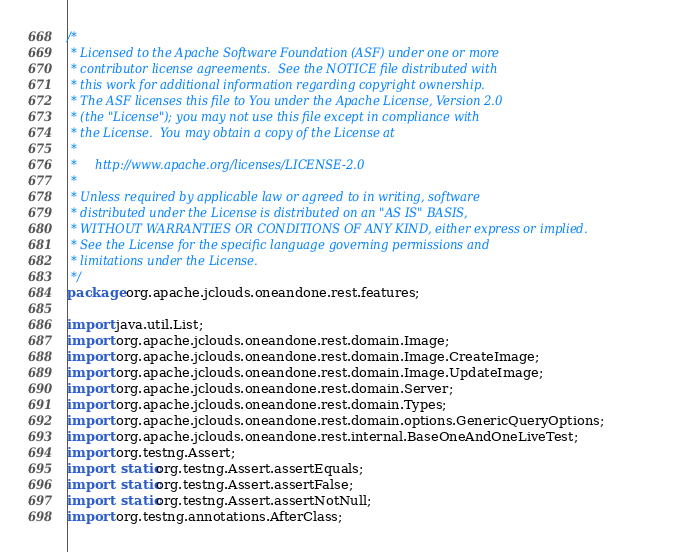Convert code to text. <code><loc_0><loc_0><loc_500><loc_500><_Java_>/*
 * Licensed to the Apache Software Foundation (ASF) under one or more
 * contributor license agreements.  See the NOTICE file distributed with
 * this work for additional information regarding copyright ownership.
 * The ASF licenses this file to You under the Apache License, Version 2.0
 * (the "License"); you may not use this file except in compliance with
 * the License.  You may obtain a copy of the License at
 *
 *     http://www.apache.org/licenses/LICENSE-2.0
 *
 * Unless required by applicable law or agreed to in writing, software
 * distributed under the License is distributed on an "AS IS" BASIS,
 * WITHOUT WARRANTIES OR CONDITIONS OF ANY KIND, either express or implied.
 * See the License for the specific language governing permissions and
 * limitations under the License.
 */
package org.apache.jclouds.oneandone.rest.features;

import java.util.List;
import org.apache.jclouds.oneandone.rest.domain.Image;
import org.apache.jclouds.oneandone.rest.domain.Image.CreateImage;
import org.apache.jclouds.oneandone.rest.domain.Image.UpdateImage;
import org.apache.jclouds.oneandone.rest.domain.Server;
import org.apache.jclouds.oneandone.rest.domain.Types;
import org.apache.jclouds.oneandone.rest.domain.options.GenericQueryOptions;
import org.apache.jclouds.oneandone.rest.internal.BaseOneAndOneLiveTest;
import org.testng.Assert;
import static org.testng.Assert.assertEquals;
import static org.testng.Assert.assertFalse;
import static org.testng.Assert.assertNotNull;
import org.testng.annotations.AfterClass;</code> 